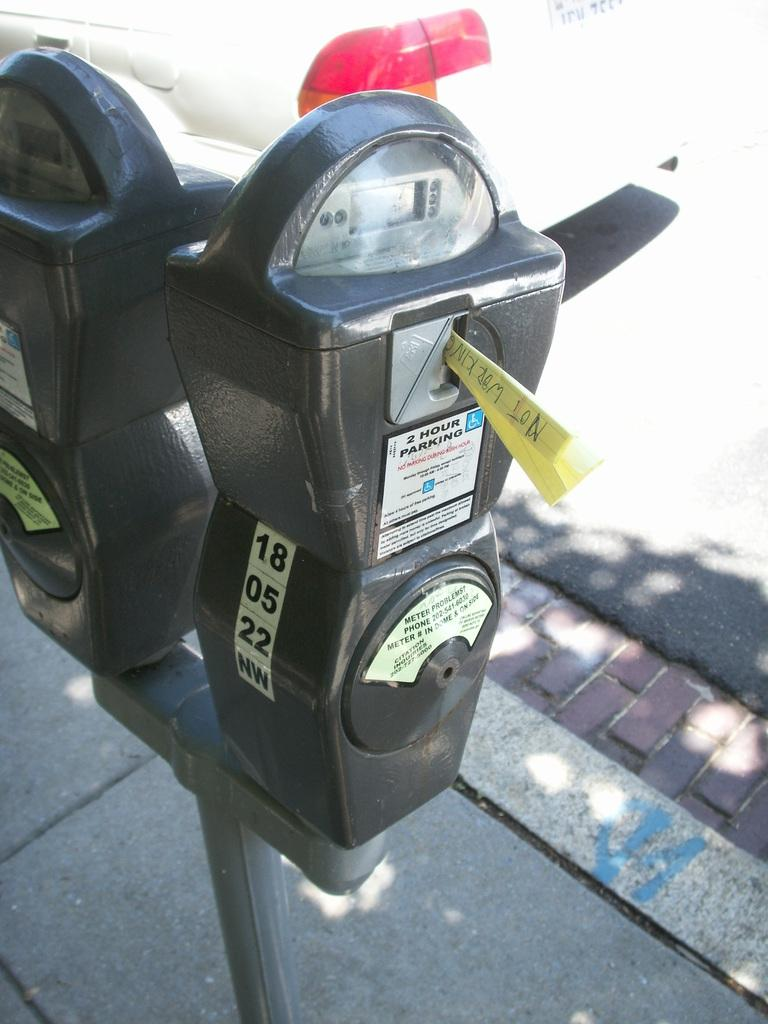Provide a one-sentence caption for the provided image. a parking meter with the number 18 on it. 